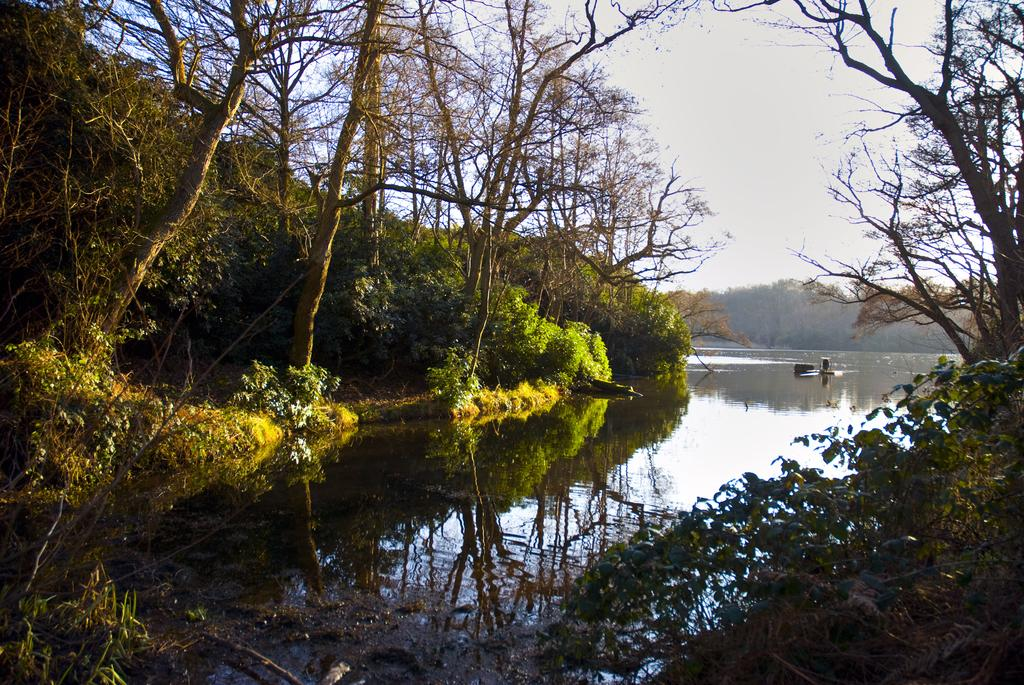What type of vegetation can be seen in the image? There are trees in the image. What else is visible besides the trees? There is water, a boat, and the sky visible in the image. Can you describe the setting of the image? The image may have been taken near a forest, given the presence of trees. How many grapes are hanging from the trees in the image? There are no grapes visible in the image; it features trees, water, a boat, and the sky. What level of experience does the deer have in navigating the boat in the image? There is no deer present in the image, so it is not possible to determine its level of experience in navigating the boat. 